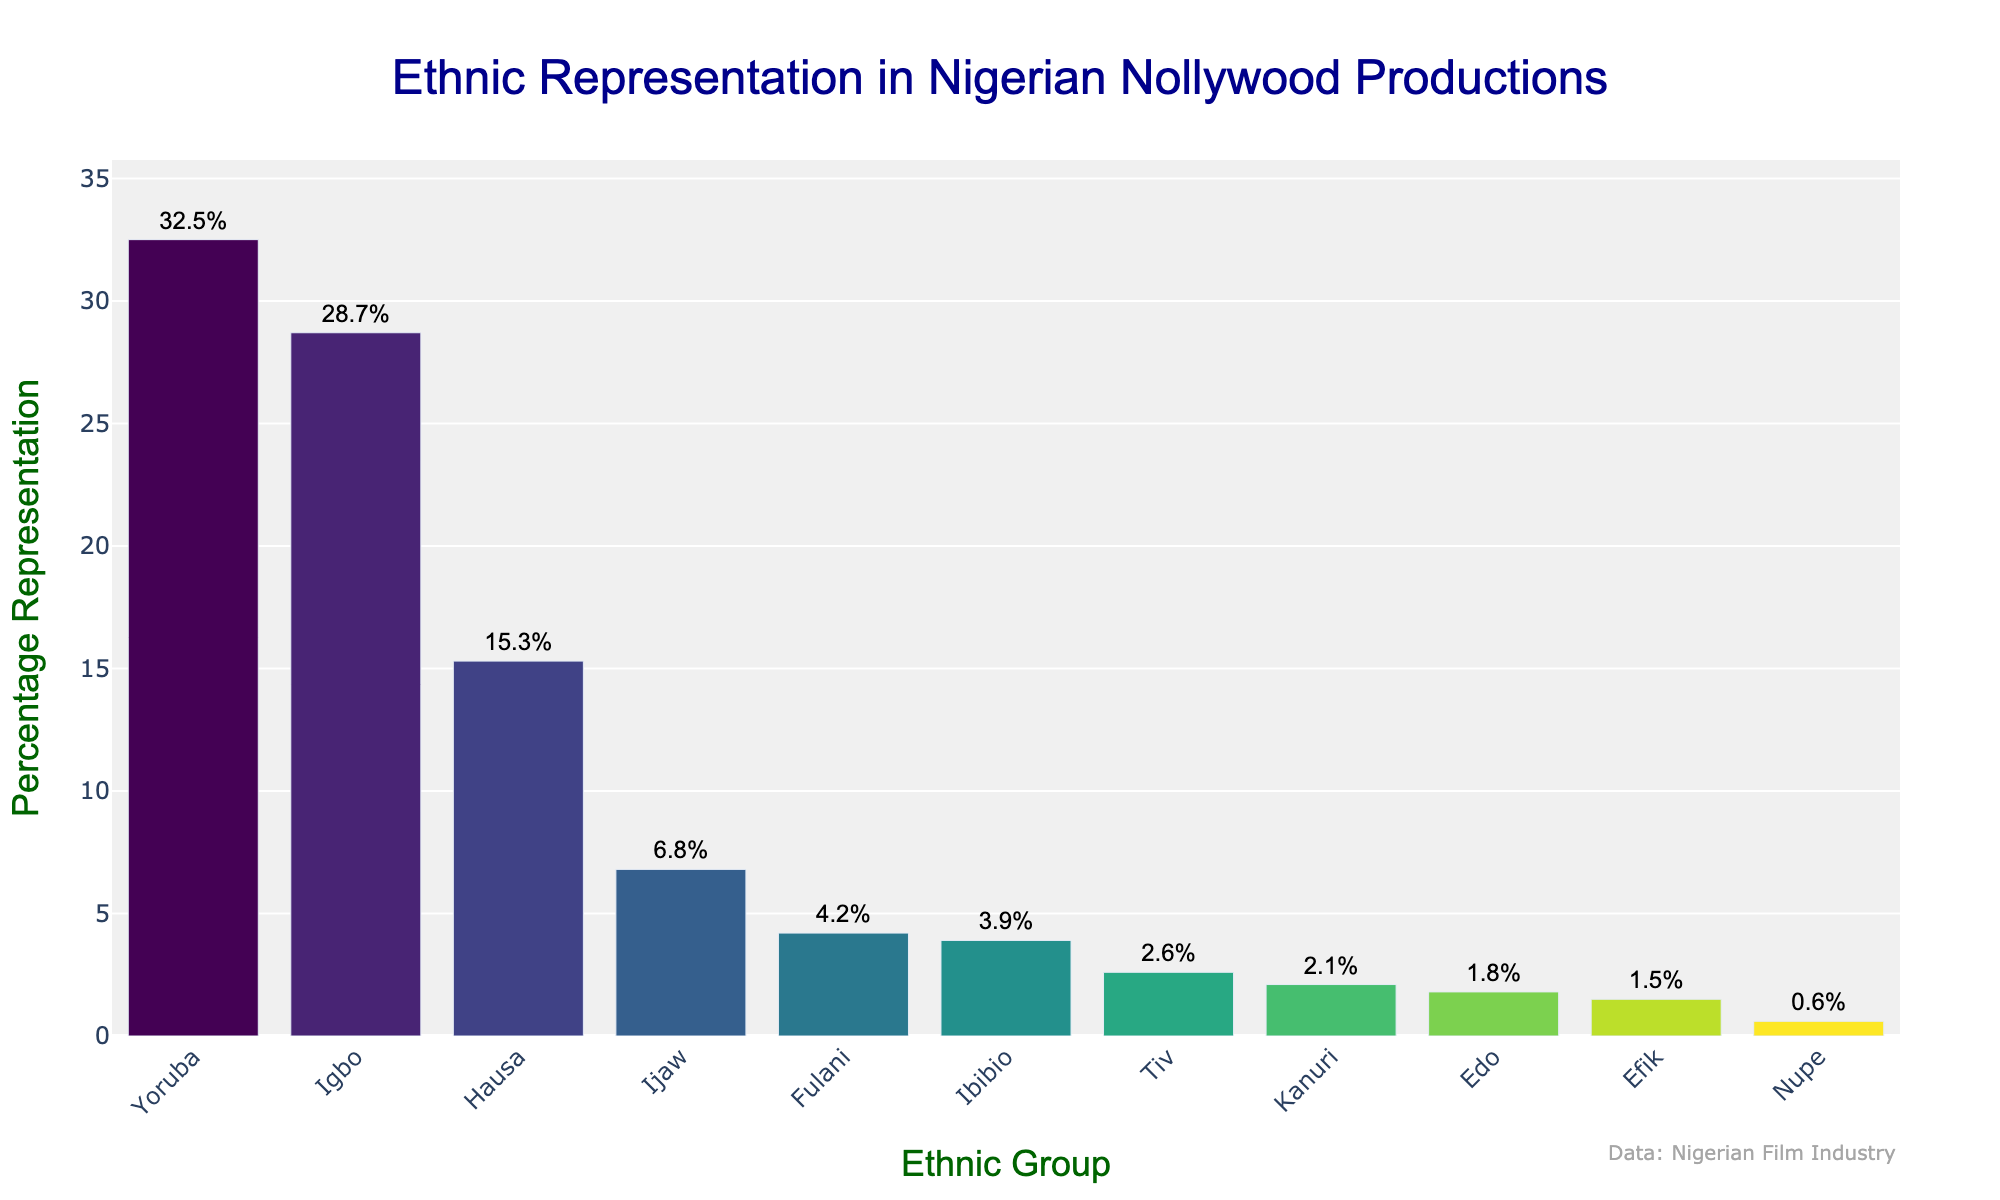Which ethnic group has the highest representation in Nigerian Nollywood productions? By observing the figure, the tallest bar represents the Yoruba ethnic group with a percentage of 32.5%.
Answer: Yoruba Which two ethnic groups have a combined representation of over 50%? Adding the percentages of the Yoruba (32.5%) and the Igbo (28.7%) groups, the result is 32.5 + 28.7 = 61.2%, which is over 50%.
Answer: Yoruba and Igbo Compare the representation of the Ijaw and Fulani ethnic groups. Which group has a higher percentage? The Ijaw bar shows a percentage of 6.8%, whereas the Fulani bar shows a percentage of 4.2%. Hence, Ijaw has a higher percentage.
Answer: Ijaw What is the sum of the representations of the Hausa, Ibibio, and Tiv ethnic groups? Summing the percentages, Hausa is 15.3%, Ibibio is 3.9%, and Tiv is 2.6%. Adding them together, 15.3 + 3.9 + 2.6 = 21.8%.
Answer: 21.8% How much greater is the representation of the Yoruba ethnic group compared to the Nupe ethnic group? Subtracting the percentage of Nupe (0.6%) from Yoruba (32.5%), the difference is 32.5 - 0.6 = 31.9%.
Answer: 31.9% Which ethnic group has the second lowest representation, and what is its percentage? By examining the bars from the shortest to the tallest, the second lowest bar represents the Nupe ethnic group with a percentage of 0.6%.
Answer: Nupe, 0.6% How many ethnic groups have a representation of less than 5%? Evaluating the bars that are lower than 5%: Fulani (4.2%), Ibibio (3.9%), Tiv (2.6%), Kanuri (2.1%), Edo (1.8%), Efik (1.5%), and Nupe (0.6%). There are 7 in total.
Answer: 7 If you combine the representation percentages of the Igbo, Yoruba, and Hausa ethnic groups, what percentage do you get? Summing the percentages: Igbo (28.7%) + Yoruba (32.5%) + Hausa (15.3%), we get 28.7 + 32.5 + 15.3 = 76.5%.
Answer: 76.5% Which ethnic group's representation is closest to 5%, and what is the exact percentage? By looking at the bars, the Ijaw ethnic group's representation is 6.8%, which is closest to 5%.
Answer: Ijaw, 6.8% What is the average percentage representation of ethnic groups with more than 10% representation? Ethnic groups with more than 10% representation are Yoruba (32.5%), Igbo (28.7%), and Hausa (15.3%). The average is calculated as (32.5 + 28.7 + 15.3) / 3 = 76.5 / 3 = 25.5%.
Answer: 25.5% 